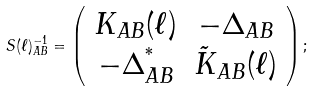<formula> <loc_0><loc_0><loc_500><loc_500>S ( \ell ) ^ { - 1 } _ { A B } = \left ( \begin{array} { c c } K _ { A B } ( \ell ) & - \Delta _ { A B } \\ - \Delta ^ { ^ { * } } _ { A B } & \tilde { K } _ { A B } ( \ell ) \end{array} \right ) ;</formula> 